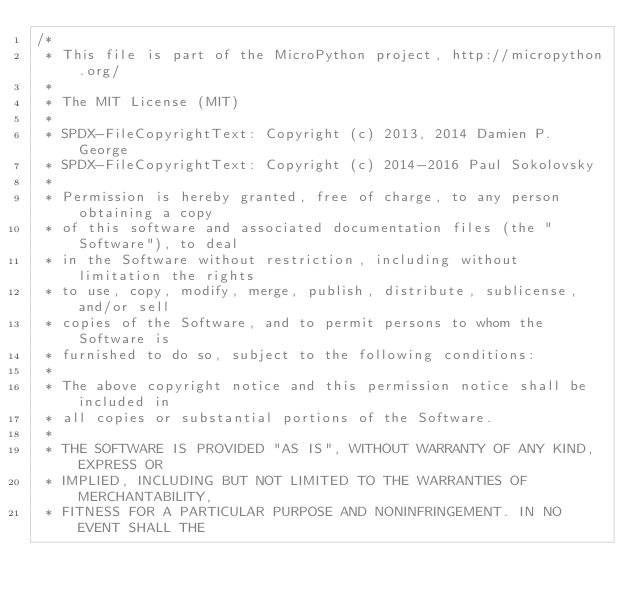Convert code to text. <code><loc_0><loc_0><loc_500><loc_500><_C_>/*
 * This file is part of the MicroPython project, http://micropython.org/
 *
 * The MIT License (MIT)
 *
 * SPDX-FileCopyrightText: Copyright (c) 2013, 2014 Damien P. George
 * SPDX-FileCopyrightText: Copyright (c) 2014-2016 Paul Sokolovsky
 *
 * Permission is hereby granted, free of charge, to any person obtaining a copy
 * of this software and associated documentation files (the "Software"), to deal
 * in the Software without restriction, including without limitation the rights
 * to use, copy, modify, merge, publish, distribute, sublicense, and/or sell
 * copies of the Software, and to permit persons to whom the Software is
 * furnished to do so, subject to the following conditions:
 *
 * The above copyright notice and this permission notice shall be included in
 * all copies or substantial portions of the Software.
 *
 * THE SOFTWARE IS PROVIDED "AS IS", WITHOUT WARRANTY OF ANY KIND, EXPRESS OR
 * IMPLIED, INCLUDING BUT NOT LIMITED TO THE WARRANTIES OF MERCHANTABILITY,
 * FITNESS FOR A PARTICULAR PURPOSE AND NONINFRINGEMENT. IN NO EVENT SHALL THE</code> 